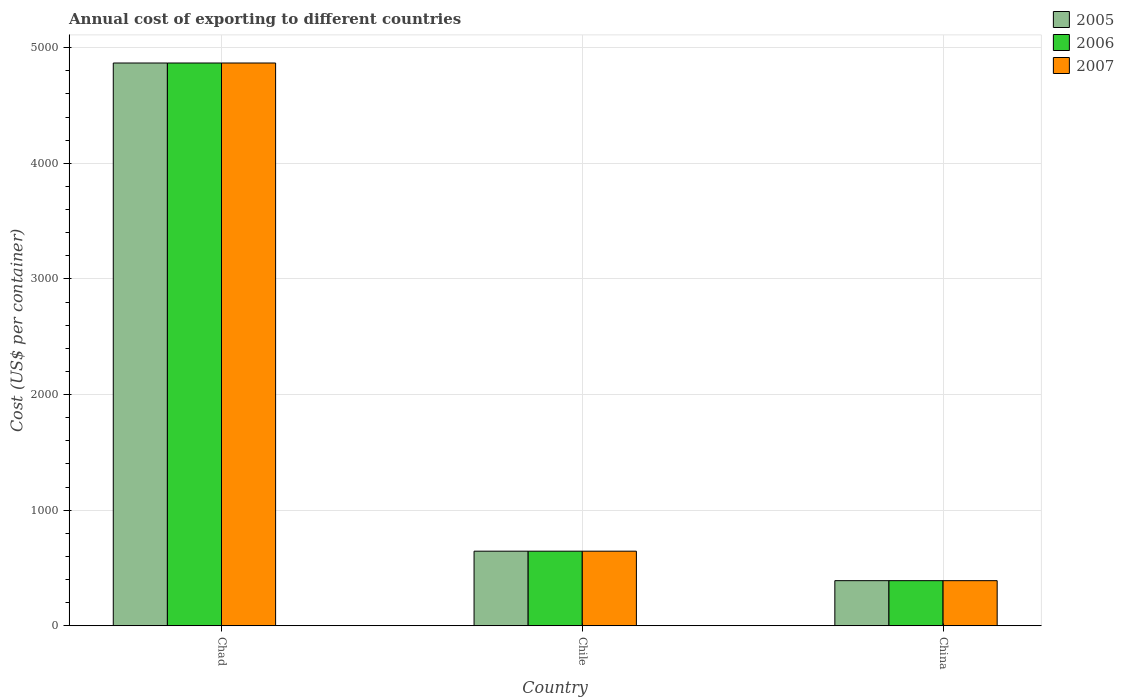Are the number of bars per tick equal to the number of legend labels?
Offer a terse response. Yes. How many bars are there on the 2nd tick from the left?
Provide a short and direct response. 3. What is the label of the 1st group of bars from the left?
Your answer should be very brief. Chad. In how many cases, is the number of bars for a given country not equal to the number of legend labels?
Give a very brief answer. 0. What is the total annual cost of exporting in 2005 in China?
Your response must be concise. 390. Across all countries, what is the maximum total annual cost of exporting in 2005?
Provide a succinct answer. 4867. Across all countries, what is the minimum total annual cost of exporting in 2006?
Your response must be concise. 390. In which country was the total annual cost of exporting in 2006 maximum?
Your answer should be very brief. Chad. What is the total total annual cost of exporting in 2006 in the graph?
Make the answer very short. 5902. What is the difference between the total annual cost of exporting in 2005 in Chad and that in China?
Your answer should be compact. 4477. What is the difference between the total annual cost of exporting in 2006 in China and the total annual cost of exporting in 2005 in Chile?
Your answer should be compact. -255. What is the average total annual cost of exporting in 2006 per country?
Keep it short and to the point. 1967.33. What is the difference between the total annual cost of exporting of/in 2007 and total annual cost of exporting of/in 2006 in Chile?
Your answer should be very brief. 0. What is the ratio of the total annual cost of exporting in 2006 in Chile to that in China?
Your answer should be very brief. 1.65. Is the total annual cost of exporting in 2006 in Chile less than that in China?
Keep it short and to the point. No. What is the difference between the highest and the second highest total annual cost of exporting in 2007?
Provide a succinct answer. 4222. What is the difference between the highest and the lowest total annual cost of exporting in 2006?
Provide a short and direct response. 4477. In how many countries, is the total annual cost of exporting in 2005 greater than the average total annual cost of exporting in 2005 taken over all countries?
Make the answer very short. 1. Is the sum of the total annual cost of exporting in 2006 in Chad and China greater than the maximum total annual cost of exporting in 2005 across all countries?
Offer a very short reply. Yes. What does the 1st bar from the left in Chile represents?
Ensure brevity in your answer.  2005. What does the 1st bar from the right in Chile represents?
Make the answer very short. 2007. How many bars are there?
Give a very brief answer. 9. What is the difference between two consecutive major ticks on the Y-axis?
Give a very brief answer. 1000. Where does the legend appear in the graph?
Offer a very short reply. Top right. How many legend labels are there?
Your answer should be very brief. 3. What is the title of the graph?
Provide a short and direct response. Annual cost of exporting to different countries. What is the label or title of the Y-axis?
Provide a short and direct response. Cost (US$ per container). What is the Cost (US$ per container) of 2005 in Chad?
Give a very brief answer. 4867. What is the Cost (US$ per container) of 2006 in Chad?
Keep it short and to the point. 4867. What is the Cost (US$ per container) of 2007 in Chad?
Ensure brevity in your answer.  4867. What is the Cost (US$ per container) in 2005 in Chile?
Provide a succinct answer. 645. What is the Cost (US$ per container) of 2006 in Chile?
Keep it short and to the point. 645. What is the Cost (US$ per container) in 2007 in Chile?
Ensure brevity in your answer.  645. What is the Cost (US$ per container) in 2005 in China?
Give a very brief answer. 390. What is the Cost (US$ per container) of 2006 in China?
Offer a very short reply. 390. What is the Cost (US$ per container) of 2007 in China?
Your answer should be very brief. 390. Across all countries, what is the maximum Cost (US$ per container) in 2005?
Offer a terse response. 4867. Across all countries, what is the maximum Cost (US$ per container) of 2006?
Your answer should be compact. 4867. Across all countries, what is the maximum Cost (US$ per container) of 2007?
Provide a succinct answer. 4867. Across all countries, what is the minimum Cost (US$ per container) in 2005?
Your answer should be very brief. 390. Across all countries, what is the minimum Cost (US$ per container) in 2006?
Offer a terse response. 390. Across all countries, what is the minimum Cost (US$ per container) in 2007?
Ensure brevity in your answer.  390. What is the total Cost (US$ per container) of 2005 in the graph?
Your answer should be compact. 5902. What is the total Cost (US$ per container) in 2006 in the graph?
Offer a terse response. 5902. What is the total Cost (US$ per container) of 2007 in the graph?
Offer a terse response. 5902. What is the difference between the Cost (US$ per container) in 2005 in Chad and that in Chile?
Your answer should be very brief. 4222. What is the difference between the Cost (US$ per container) in 2006 in Chad and that in Chile?
Provide a short and direct response. 4222. What is the difference between the Cost (US$ per container) of 2007 in Chad and that in Chile?
Ensure brevity in your answer.  4222. What is the difference between the Cost (US$ per container) in 2005 in Chad and that in China?
Offer a terse response. 4477. What is the difference between the Cost (US$ per container) of 2006 in Chad and that in China?
Offer a terse response. 4477. What is the difference between the Cost (US$ per container) of 2007 in Chad and that in China?
Make the answer very short. 4477. What is the difference between the Cost (US$ per container) in 2005 in Chile and that in China?
Provide a short and direct response. 255. What is the difference between the Cost (US$ per container) of 2006 in Chile and that in China?
Provide a short and direct response. 255. What is the difference between the Cost (US$ per container) of 2007 in Chile and that in China?
Your answer should be compact. 255. What is the difference between the Cost (US$ per container) of 2005 in Chad and the Cost (US$ per container) of 2006 in Chile?
Give a very brief answer. 4222. What is the difference between the Cost (US$ per container) in 2005 in Chad and the Cost (US$ per container) in 2007 in Chile?
Offer a very short reply. 4222. What is the difference between the Cost (US$ per container) of 2006 in Chad and the Cost (US$ per container) of 2007 in Chile?
Provide a short and direct response. 4222. What is the difference between the Cost (US$ per container) in 2005 in Chad and the Cost (US$ per container) in 2006 in China?
Your answer should be compact. 4477. What is the difference between the Cost (US$ per container) of 2005 in Chad and the Cost (US$ per container) of 2007 in China?
Make the answer very short. 4477. What is the difference between the Cost (US$ per container) of 2006 in Chad and the Cost (US$ per container) of 2007 in China?
Your response must be concise. 4477. What is the difference between the Cost (US$ per container) in 2005 in Chile and the Cost (US$ per container) in 2006 in China?
Give a very brief answer. 255. What is the difference between the Cost (US$ per container) in 2005 in Chile and the Cost (US$ per container) in 2007 in China?
Offer a terse response. 255. What is the difference between the Cost (US$ per container) in 2006 in Chile and the Cost (US$ per container) in 2007 in China?
Ensure brevity in your answer.  255. What is the average Cost (US$ per container) in 2005 per country?
Offer a terse response. 1967.33. What is the average Cost (US$ per container) of 2006 per country?
Your answer should be compact. 1967.33. What is the average Cost (US$ per container) of 2007 per country?
Your answer should be compact. 1967.33. What is the difference between the Cost (US$ per container) in 2005 and Cost (US$ per container) in 2007 in Chile?
Keep it short and to the point. 0. What is the difference between the Cost (US$ per container) in 2006 and Cost (US$ per container) in 2007 in Chile?
Provide a short and direct response. 0. What is the difference between the Cost (US$ per container) in 2005 and Cost (US$ per container) in 2006 in China?
Offer a very short reply. 0. What is the difference between the Cost (US$ per container) in 2005 and Cost (US$ per container) in 2007 in China?
Provide a succinct answer. 0. What is the difference between the Cost (US$ per container) of 2006 and Cost (US$ per container) of 2007 in China?
Provide a succinct answer. 0. What is the ratio of the Cost (US$ per container) in 2005 in Chad to that in Chile?
Your answer should be compact. 7.55. What is the ratio of the Cost (US$ per container) of 2006 in Chad to that in Chile?
Ensure brevity in your answer.  7.55. What is the ratio of the Cost (US$ per container) of 2007 in Chad to that in Chile?
Your answer should be very brief. 7.55. What is the ratio of the Cost (US$ per container) in 2005 in Chad to that in China?
Provide a short and direct response. 12.48. What is the ratio of the Cost (US$ per container) of 2006 in Chad to that in China?
Your response must be concise. 12.48. What is the ratio of the Cost (US$ per container) of 2007 in Chad to that in China?
Ensure brevity in your answer.  12.48. What is the ratio of the Cost (US$ per container) of 2005 in Chile to that in China?
Offer a terse response. 1.65. What is the ratio of the Cost (US$ per container) in 2006 in Chile to that in China?
Give a very brief answer. 1.65. What is the ratio of the Cost (US$ per container) of 2007 in Chile to that in China?
Keep it short and to the point. 1.65. What is the difference between the highest and the second highest Cost (US$ per container) of 2005?
Make the answer very short. 4222. What is the difference between the highest and the second highest Cost (US$ per container) in 2006?
Ensure brevity in your answer.  4222. What is the difference between the highest and the second highest Cost (US$ per container) of 2007?
Your answer should be compact. 4222. What is the difference between the highest and the lowest Cost (US$ per container) of 2005?
Give a very brief answer. 4477. What is the difference between the highest and the lowest Cost (US$ per container) of 2006?
Give a very brief answer. 4477. What is the difference between the highest and the lowest Cost (US$ per container) of 2007?
Your response must be concise. 4477. 